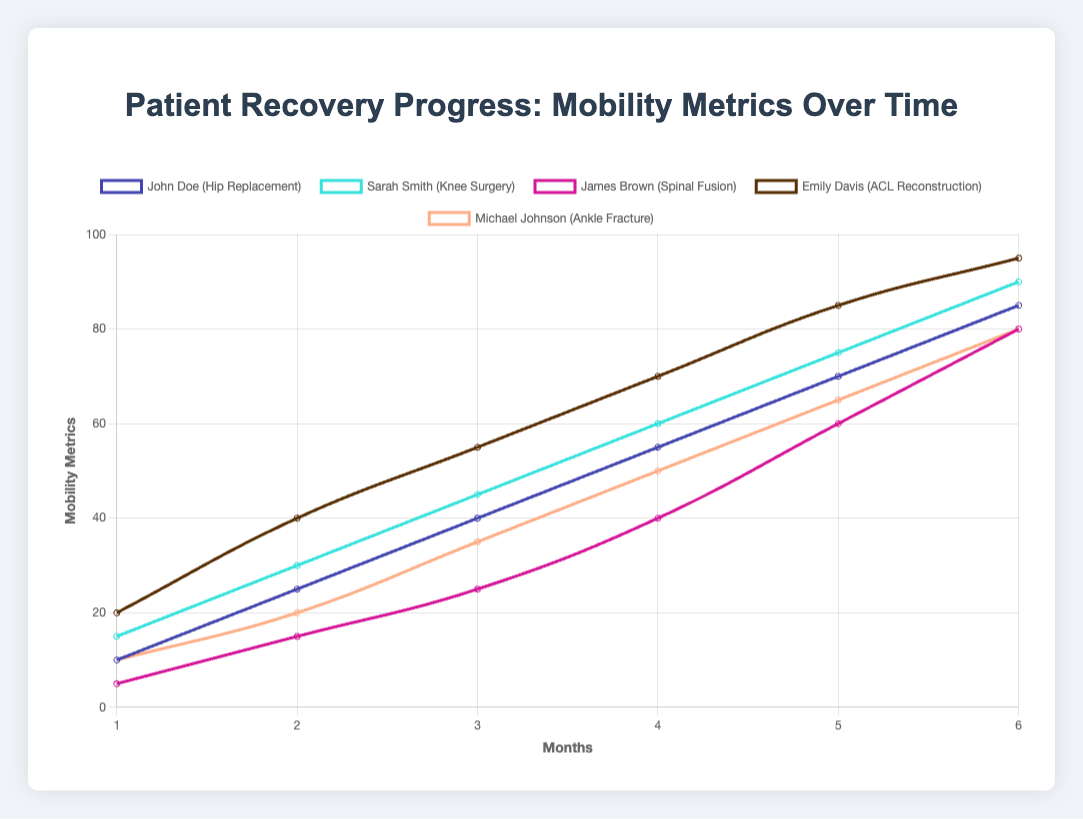Which patient showed the fastest initial increase in mobility metrics in the first month? Sarah Smith showed the fastest initial increase as her mobility metric increased from 0 to 15 in the first month.
Answer: Sarah Smith During which month did James Brown show the greatest increase in mobility metrics? Between the 5th and 6th month, James Brown showed an increase from 60 to 80, which is a rise of 20 points.
Answer: 5th to 6th month What is the difference between the mobility metrics of John Doe and Emily Davis in the 4th month? In the 4th month, John Doe's mobility metric is 55 and Emily Davis's is 70. The difference is 70 - 55 = 15.
Answer: 15 Which patient reached the highest mobility metric by the end of the 6th month? By the 6th month, Emily Davis reached the highest mobility metric with a value of 95.
Answer: Emily Davis How much did Michael Johnson’s mobility metric change between the 2nd and 3rd month? Michael Johnson’s mobility metric changed from 20 to 35 between the 2nd and 3rd month, which is an increase of 35 - 20 = 15.
Answer: 15 On average, how much did John Doe’s mobility metrics increase per month over the 6-month period? The total increase in John Doe’s mobility metrics over 6 months is 85 - 10 = 75. The average monthly increase is 75 / 6 = 12.5.
Answer: 12.5 Which patient showed a consistent increase in mobility metrics without any decrease throughout the 6 months? All the patients showed consistent increases in their mobility metrics each month.
Answer: All patients Who had the lowest mobility metric in the 3rd month, and what was the value? In the 3rd month, James Brown had the lowest mobility metric with a value of 25.
Answer: James Brown, 25 What is the combined increase in mobility metrics for all patients from the 1st to the 6th month? The combined increase for all patients is: 
John Doe (85 - 10) = 75
Sarah Smith (90 - 15) = 75
James Brown (80 - 5) = 75
Emily Davis (95 - 20) = 75
Michael Johnson (80 - 10) = 70
The combined increase is 75 + 75 + 75 + 75 + 70 = 370.
Answer: 370 Compare the total mobility metric increase of Michael Johnson with that of James Brown. Who had a higher increase, and by how much? Michael Johnson's increase is 70 (80 - 10), and James Brown's increase is 75 (80 - 5). James Brown had a higher increase by 5 points.
Answer: James Brown by 5 